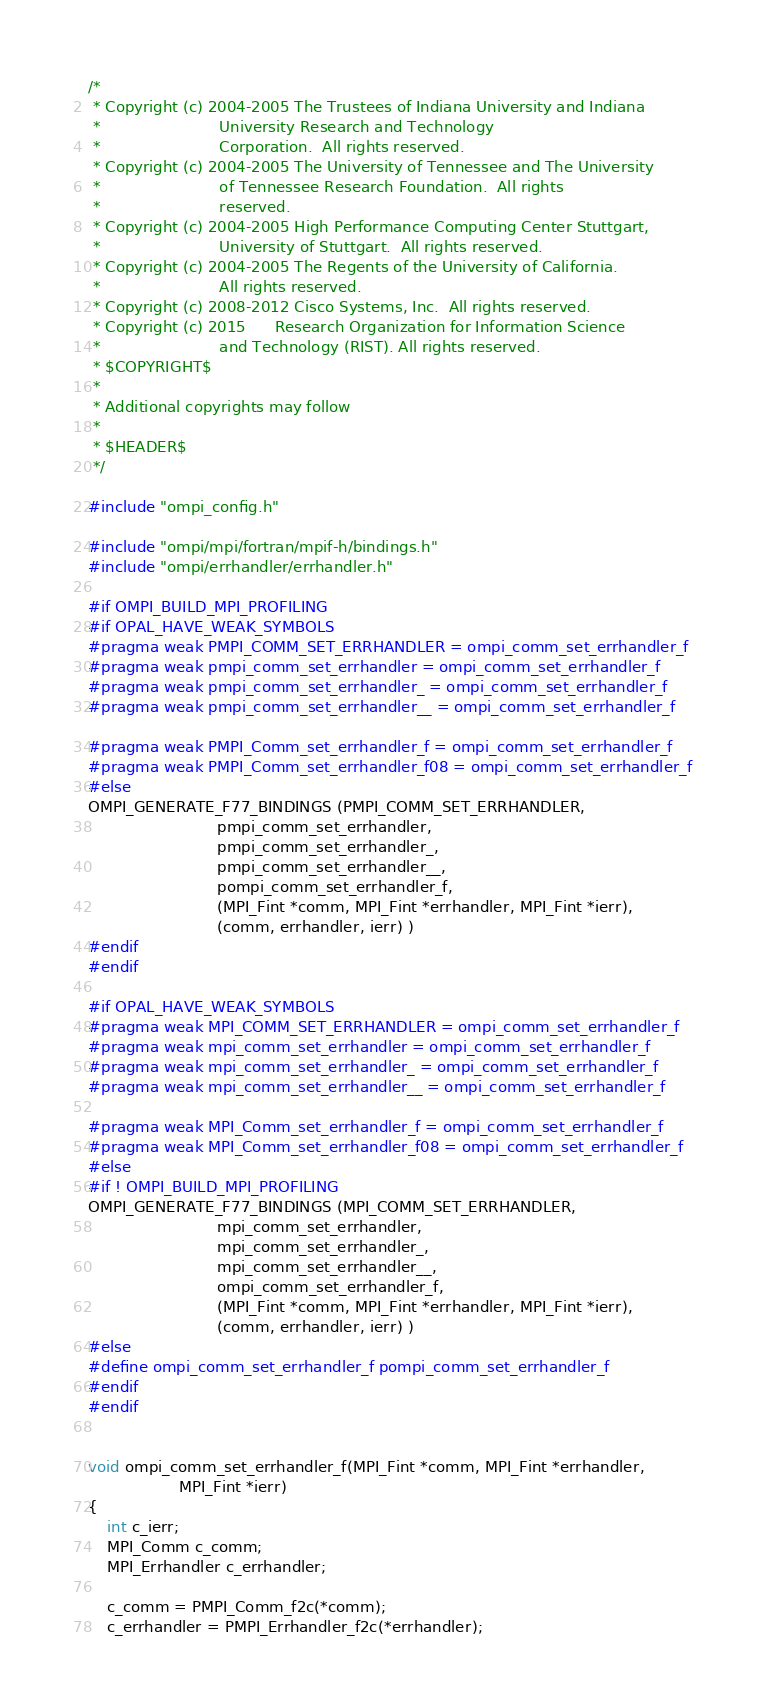<code> <loc_0><loc_0><loc_500><loc_500><_C_>/*
 * Copyright (c) 2004-2005 The Trustees of Indiana University and Indiana
 *                         University Research and Technology
 *                         Corporation.  All rights reserved.
 * Copyright (c) 2004-2005 The University of Tennessee and The University
 *                         of Tennessee Research Foundation.  All rights
 *                         reserved.
 * Copyright (c) 2004-2005 High Performance Computing Center Stuttgart,
 *                         University of Stuttgart.  All rights reserved.
 * Copyright (c) 2004-2005 The Regents of the University of California.
 *                         All rights reserved.
 * Copyright (c) 2008-2012 Cisco Systems, Inc.  All rights reserved.
 * Copyright (c) 2015      Research Organization for Information Science
 *                         and Technology (RIST). All rights reserved.
 * $COPYRIGHT$
 *
 * Additional copyrights may follow
 *
 * $HEADER$
 */

#include "ompi_config.h"

#include "ompi/mpi/fortran/mpif-h/bindings.h"
#include "ompi/errhandler/errhandler.h"

#if OMPI_BUILD_MPI_PROFILING
#if OPAL_HAVE_WEAK_SYMBOLS
#pragma weak PMPI_COMM_SET_ERRHANDLER = ompi_comm_set_errhandler_f
#pragma weak pmpi_comm_set_errhandler = ompi_comm_set_errhandler_f
#pragma weak pmpi_comm_set_errhandler_ = ompi_comm_set_errhandler_f
#pragma weak pmpi_comm_set_errhandler__ = ompi_comm_set_errhandler_f

#pragma weak PMPI_Comm_set_errhandler_f = ompi_comm_set_errhandler_f
#pragma weak PMPI_Comm_set_errhandler_f08 = ompi_comm_set_errhandler_f
#else
OMPI_GENERATE_F77_BINDINGS (PMPI_COMM_SET_ERRHANDLER,
                           pmpi_comm_set_errhandler,
                           pmpi_comm_set_errhandler_,
                           pmpi_comm_set_errhandler__,
                           pompi_comm_set_errhandler_f,
                           (MPI_Fint *comm, MPI_Fint *errhandler, MPI_Fint *ierr),
                           (comm, errhandler, ierr) )
#endif
#endif

#if OPAL_HAVE_WEAK_SYMBOLS
#pragma weak MPI_COMM_SET_ERRHANDLER = ompi_comm_set_errhandler_f
#pragma weak mpi_comm_set_errhandler = ompi_comm_set_errhandler_f
#pragma weak mpi_comm_set_errhandler_ = ompi_comm_set_errhandler_f
#pragma weak mpi_comm_set_errhandler__ = ompi_comm_set_errhandler_f

#pragma weak MPI_Comm_set_errhandler_f = ompi_comm_set_errhandler_f
#pragma weak MPI_Comm_set_errhandler_f08 = ompi_comm_set_errhandler_f
#else
#if ! OMPI_BUILD_MPI_PROFILING
OMPI_GENERATE_F77_BINDINGS (MPI_COMM_SET_ERRHANDLER,
                           mpi_comm_set_errhandler,
                           mpi_comm_set_errhandler_,
                           mpi_comm_set_errhandler__,
                           ompi_comm_set_errhandler_f,
                           (MPI_Fint *comm, MPI_Fint *errhandler, MPI_Fint *ierr),
                           (comm, errhandler, ierr) )
#else
#define ompi_comm_set_errhandler_f pompi_comm_set_errhandler_f
#endif
#endif


void ompi_comm_set_errhandler_f(MPI_Fint *comm, MPI_Fint *errhandler,
			       MPI_Fint *ierr)
{
    int c_ierr;
    MPI_Comm c_comm;
    MPI_Errhandler c_errhandler;

    c_comm = PMPI_Comm_f2c(*comm);
    c_errhandler = PMPI_Errhandler_f2c(*errhandler);
</code> 